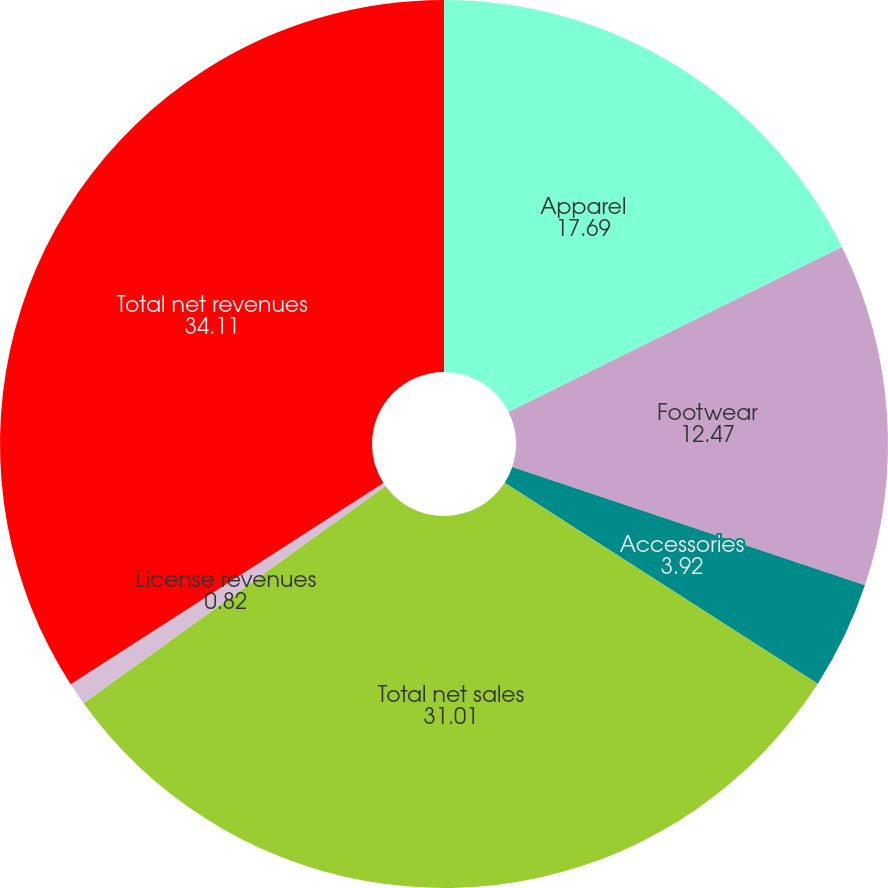Convert chart to OTSL. <chart><loc_0><loc_0><loc_500><loc_500><pie_chart><fcel>Apparel<fcel>Footwear<fcel>Accessories<fcel>Total net sales<fcel>License revenues<fcel>Total net revenues<nl><fcel>17.69%<fcel>12.47%<fcel>3.92%<fcel>31.01%<fcel>0.82%<fcel>34.11%<nl></chart> 